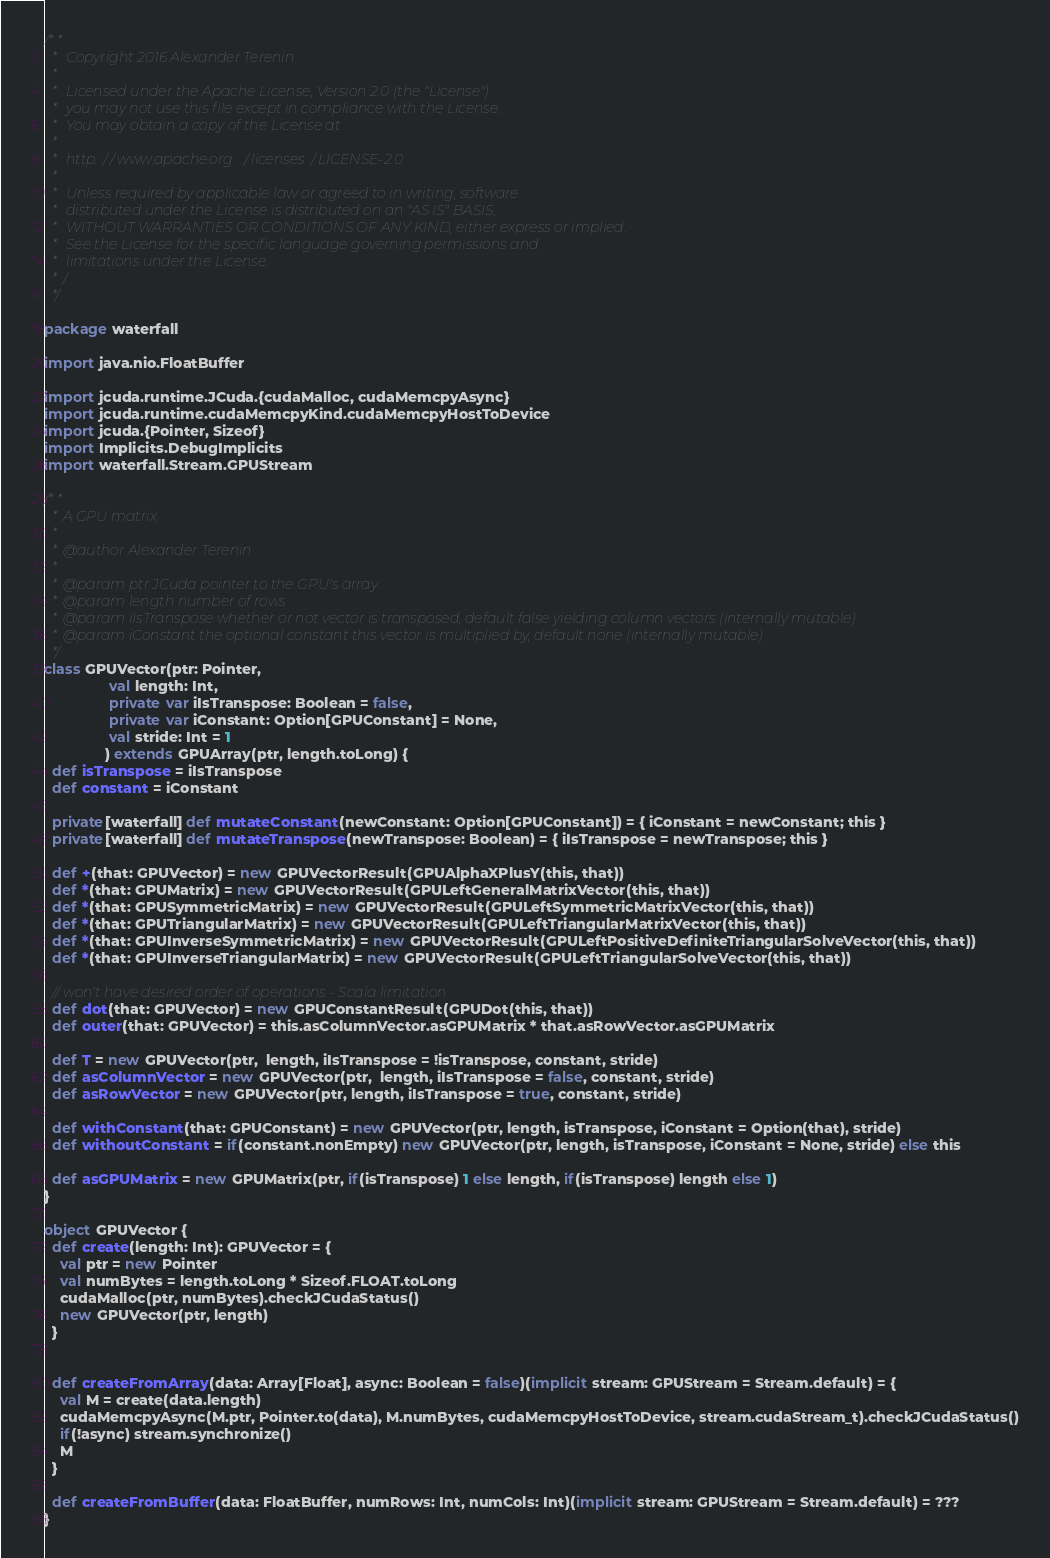<code> <loc_0><loc_0><loc_500><loc_500><_Scala_>/**
  *  Copyright 2016 Alexander Terenin
  *
  *  Licensed under the Apache License, Version 2.0 (the "License")
  *  you may not use this file except in compliance with the License.
  *  You may obtain a copy of the License at
  *
  *  http://www.apache.org/licenses/LICENSE-2.0
  *
  *  Unless required by applicable law or agreed to in writing, software
  *  distributed under the License is distributed on an "AS IS" BASIS,
  *  WITHOUT WARRANTIES OR CONDITIONS OF ANY KIND, either express or implied.
  *  See the License for the specific language governing permissions and
  *  limitations under the License.
  * /
  */

package waterfall

import java.nio.FloatBuffer

import jcuda.runtime.JCuda.{cudaMalloc, cudaMemcpyAsync}
import jcuda.runtime.cudaMemcpyKind.cudaMemcpyHostToDevice
import jcuda.{Pointer, Sizeof}
import Implicits.DebugImplicits
import waterfall.Stream.GPUStream

/**
  * A GPU matrix
  *
  * @author Alexander Terenin
  *
  * @param ptr JCuda pointer to the GPU's array
  * @param length number of rows
  * @param iIsTranspose whether or not vector is transposed, default false yielding column vectors (internally mutable)
  * @param iConstant the optional constant this vector is multiplied by, default none (internally mutable)
  */
class GPUVector(ptr: Pointer,
                val length: Int,
                private var iIsTranspose: Boolean = false,
                private var iConstant: Option[GPUConstant] = None,
                val stride: Int = 1
               ) extends GPUArray(ptr, length.toLong) {
  def isTranspose = iIsTranspose
  def constant = iConstant

  private[waterfall] def mutateConstant(newConstant: Option[GPUConstant]) = { iConstant = newConstant; this }
  private[waterfall] def mutateTranspose(newTranspose: Boolean) = { iIsTranspose = newTranspose; this }

  def +(that: GPUVector) = new GPUVectorResult(GPUAlphaXPlusY(this, that))
  def *(that: GPUMatrix) = new GPUVectorResult(GPULeftGeneralMatrixVector(this, that))
  def *(that: GPUSymmetricMatrix) = new GPUVectorResult(GPULeftSymmetricMatrixVector(this, that))
  def *(that: GPUTriangularMatrix) = new GPUVectorResult(GPULeftTriangularMatrixVector(this, that))
  def *(that: GPUInverseSymmetricMatrix) = new GPUVectorResult(GPULeftPositiveDefiniteTriangularSolveVector(this, that))
  def *(that: GPUInverseTriangularMatrix) = new GPUVectorResult(GPULeftTriangularSolveVector(this, that))

  // won't have desired order of operations - Scala limitation
  def dot(that: GPUVector) = new GPUConstantResult(GPUDot(this, that))
  def outer(that: GPUVector) = this.asColumnVector.asGPUMatrix * that.asRowVector.asGPUMatrix

  def T = new GPUVector(ptr,  length, iIsTranspose = !isTranspose, constant, stride)
  def asColumnVector = new GPUVector(ptr,  length, iIsTranspose = false, constant, stride)
  def asRowVector = new GPUVector(ptr, length, iIsTranspose = true, constant, stride)

  def withConstant(that: GPUConstant) = new GPUVector(ptr, length, isTranspose, iConstant = Option(that), stride)
  def withoutConstant = if(constant.nonEmpty) new GPUVector(ptr, length, isTranspose, iConstant = None, stride) else this

  def asGPUMatrix = new GPUMatrix(ptr, if(isTranspose) 1 else length, if(isTranspose) length else 1)
}

object GPUVector {
  def create(length: Int): GPUVector = {
    val ptr = new Pointer
    val numBytes = length.toLong * Sizeof.FLOAT.toLong
    cudaMalloc(ptr, numBytes).checkJCudaStatus()
    new GPUVector(ptr, length)
  }


  def createFromArray(data: Array[Float], async: Boolean = false)(implicit stream: GPUStream = Stream.default) = {
    val M = create(data.length)
    cudaMemcpyAsync(M.ptr, Pointer.to(data), M.numBytes, cudaMemcpyHostToDevice, stream.cudaStream_t).checkJCudaStatus()
    if(!async) stream.synchronize()
    M
  }

  def createFromBuffer(data: FloatBuffer, numRows: Int, numCols: Int)(implicit stream: GPUStream = Stream.default) = ???
}</code> 